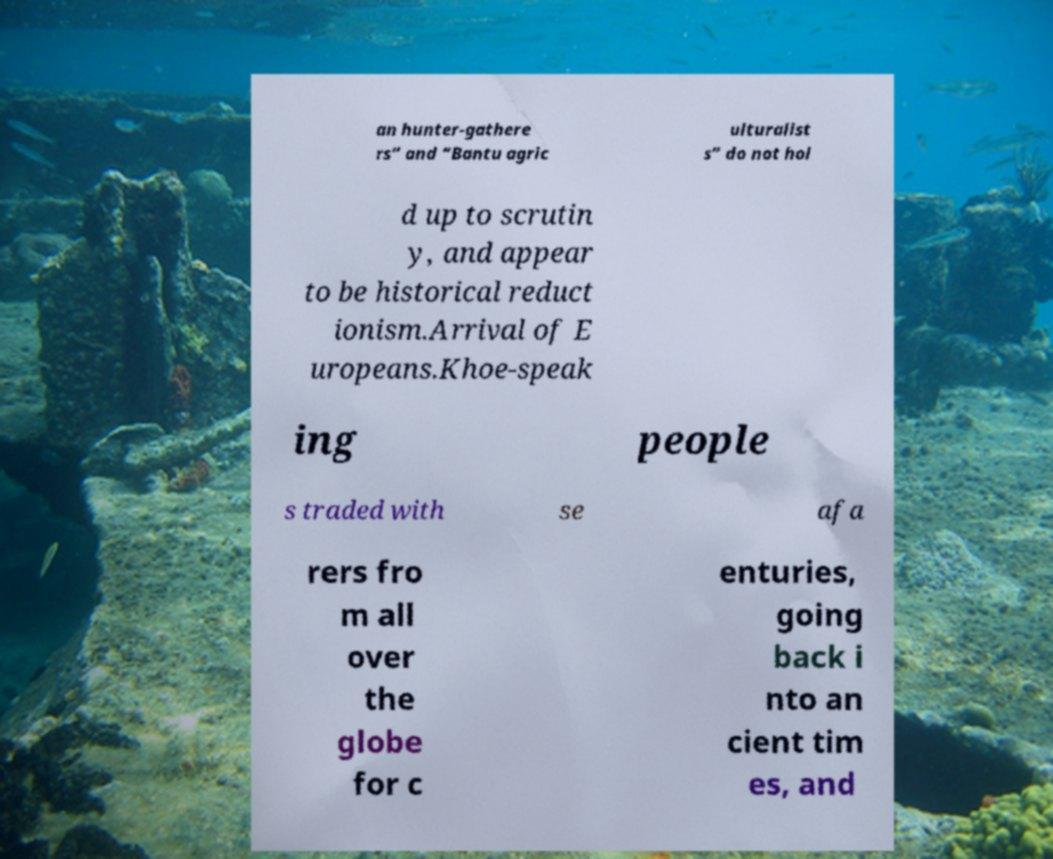What messages or text are displayed in this image? I need them in a readable, typed format. an hunter-gathere rs” and “Bantu agric ulturalist s” do not hol d up to scrutin y, and appear to be historical reduct ionism.Arrival of E uropeans.Khoe-speak ing people s traded with se afa rers fro m all over the globe for c enturies, going back i nto an cient tim es, and 